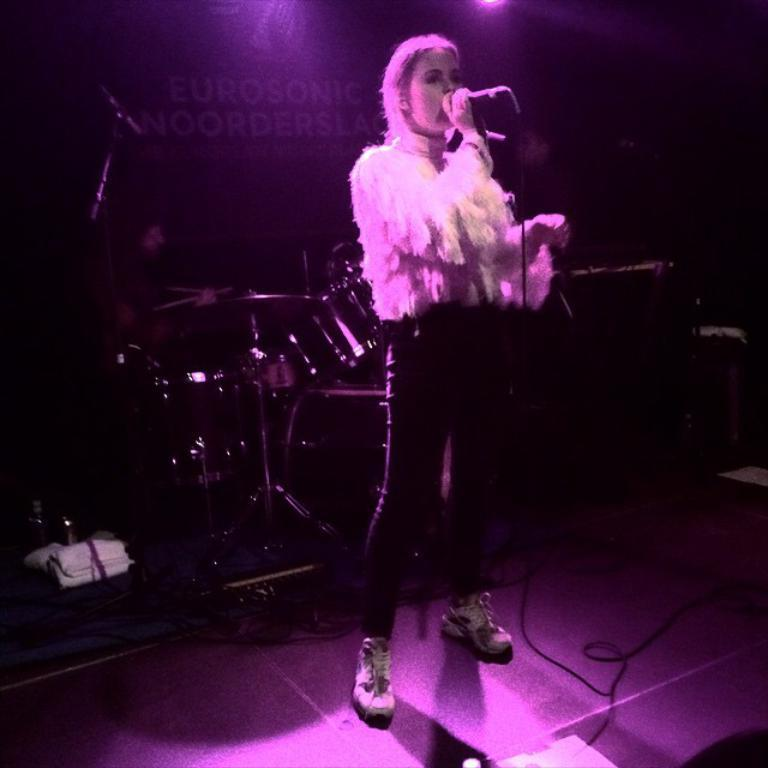Who is the main subject in the image? There is a woman in the image. Can you describe the woman's appearance? The woman is beautiful. What is the woman doing in the image? The woman is standing, singing, and holding a microphone. What is the woman wearing in the image? The woman is wearing a white top and black trousers. What else can be seen in the image besides the woman? There are musical instruments in the image. What type of trade is the woman involved in, as depicted in the image? There is no indication of any trade in the image; it simply shows a woman singing while holding a microphone. Can you tell me where the mailbox is located in the image? There is no mailbox present in the image. 